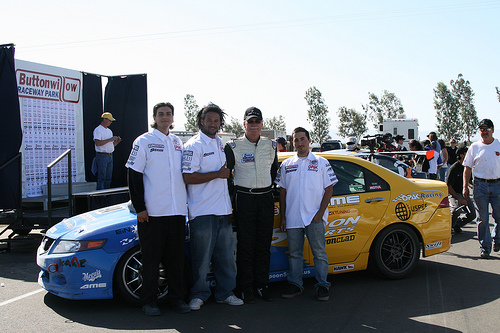<image>
Is the man behind the stage? No. The man is not behind the stage. From this viewpoint, the man appears to be positioned elsewhere in the scene. Is the man behind the car? No. The man is not behind the car. From this viewpoint, the man appears to be positioned elsewhere in the scene. Where is the old man in relation to the new car? Is it to the right of the new car? Yes. From this viewpoint, the old man is positioned to the right side relative to the new car. 